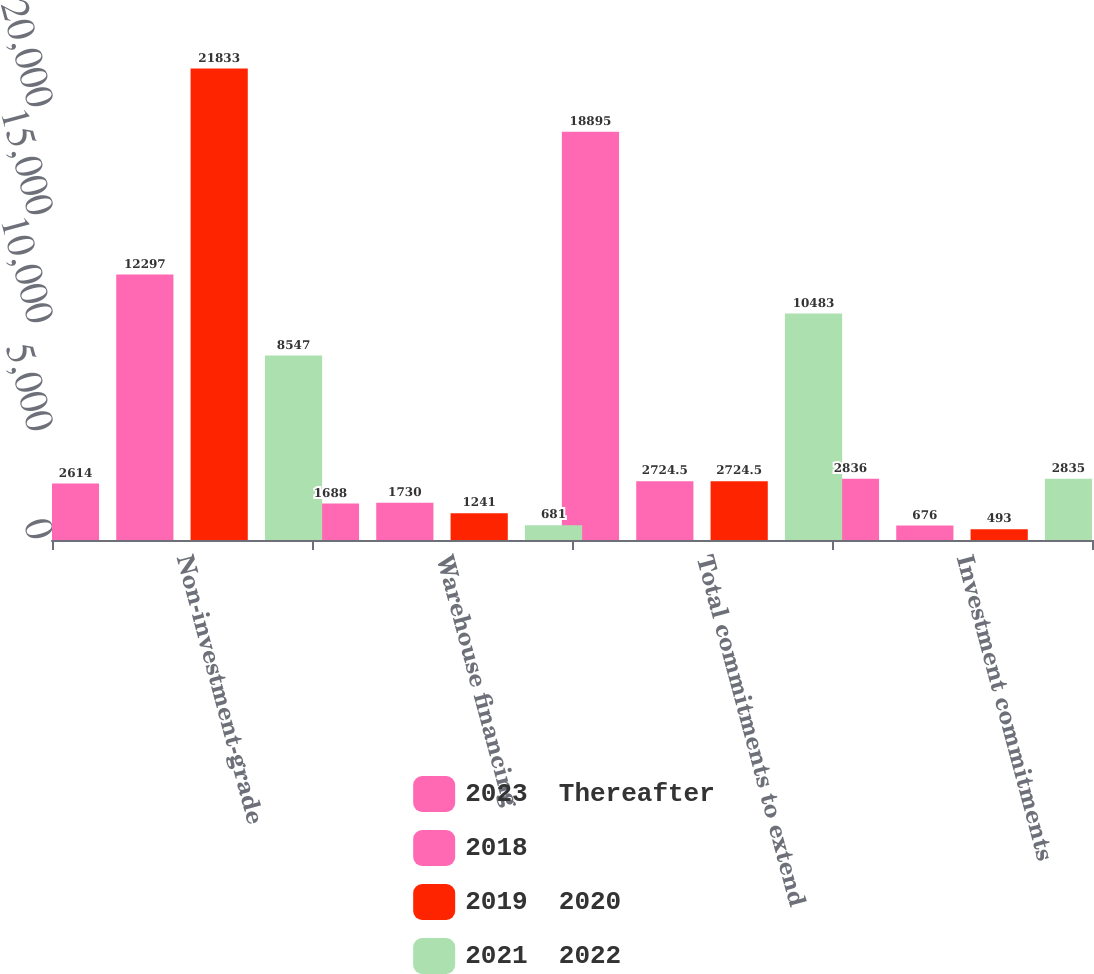<chart> <loc_0><loc_0><loc_500><loc_500><stacked_bar_chart><ecel><fcel>Non-investment-grade<fcel>Warehouse financing<fcel>Total commitments to extend<fcel>Investment commitments<nl><fcel>2023  Thereafter<fcel>2614<fcel>1688<fcel>18895<fcel>2836<nl><fcel>2018<fcel>12297<fcel>1730<fcel>2724.5<fcel>676<nl><fcel>2019  2020<fcel>21833<fcel>1241<fcel>2724.5<fcel>493<nl><fcel>2021  2022<fcel>8547<fcel>681<fcel>10483<fcel>2835<nl></chart> 